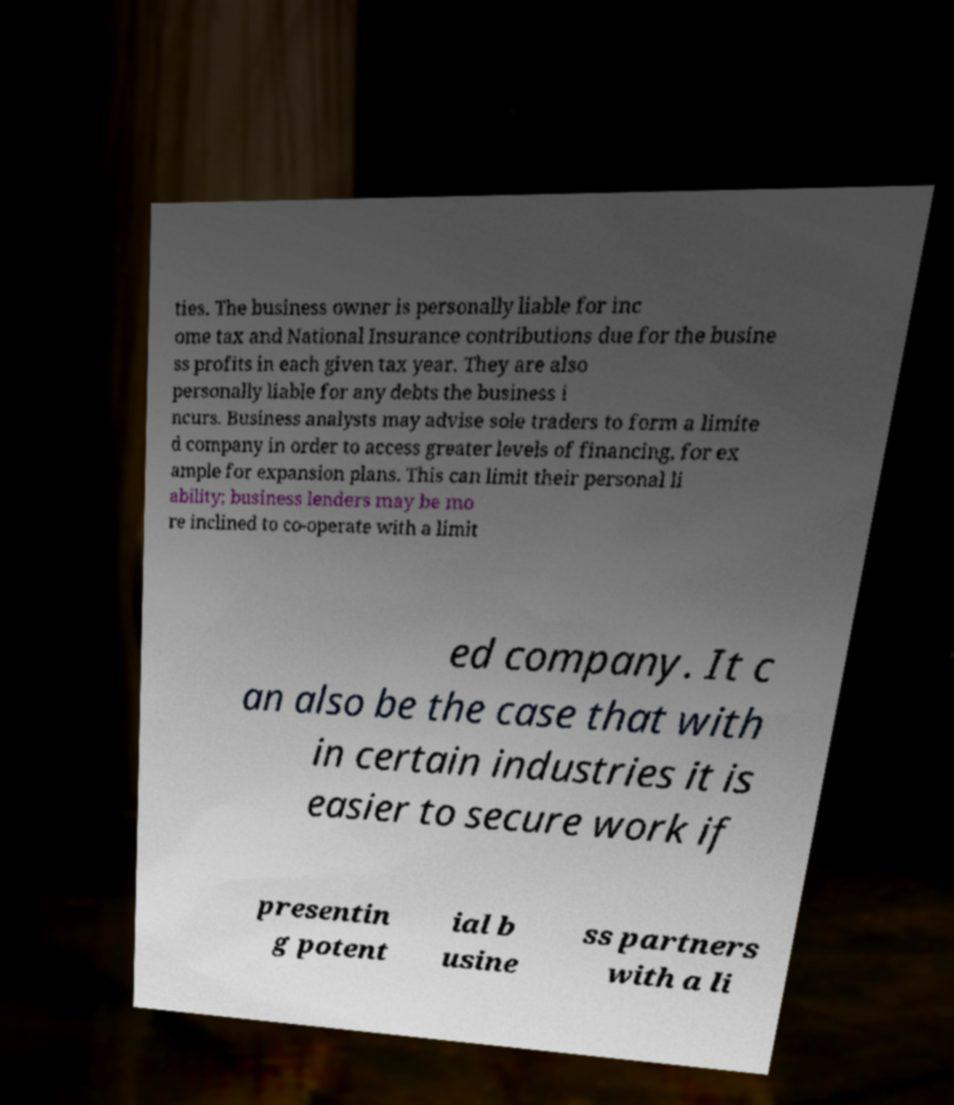For documentation purposes, I need the text within this image transcribed. Could you provide that? ties. The business owner is personally liable for inc ome tax and National Insurance contributions due for the busine ss profits in each given tax year. They are also personally liable for any debts the business i ncurs. Business analysts may advise sole traders to form a limite d company in order to access greater levels of financing, for ex ample for expansion plans. This can limit their personal li ability; business lenders may be mo re inclined to co-operate with a limit ed company. It c an also be the case that with in certain industries it is easier to secure work if presentin g potent ial b usine ss partners with a li 